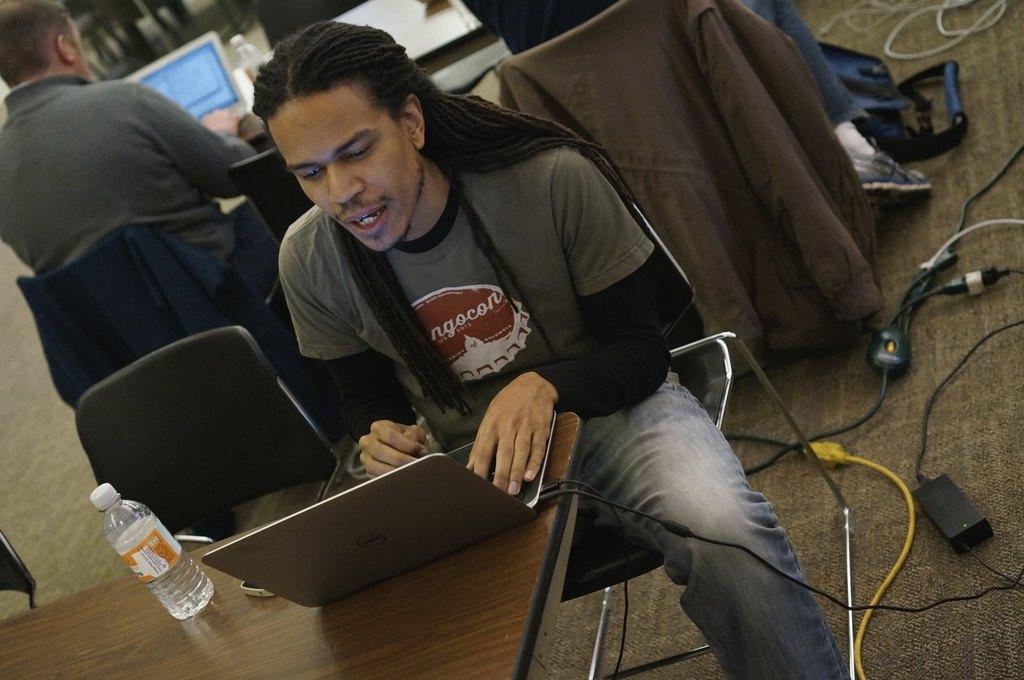Describe this image in one or two sentences. In this image I can see man is sitting on a chair in front of a table. On the table I can see a glass bottle, laptop and other objects on it. 